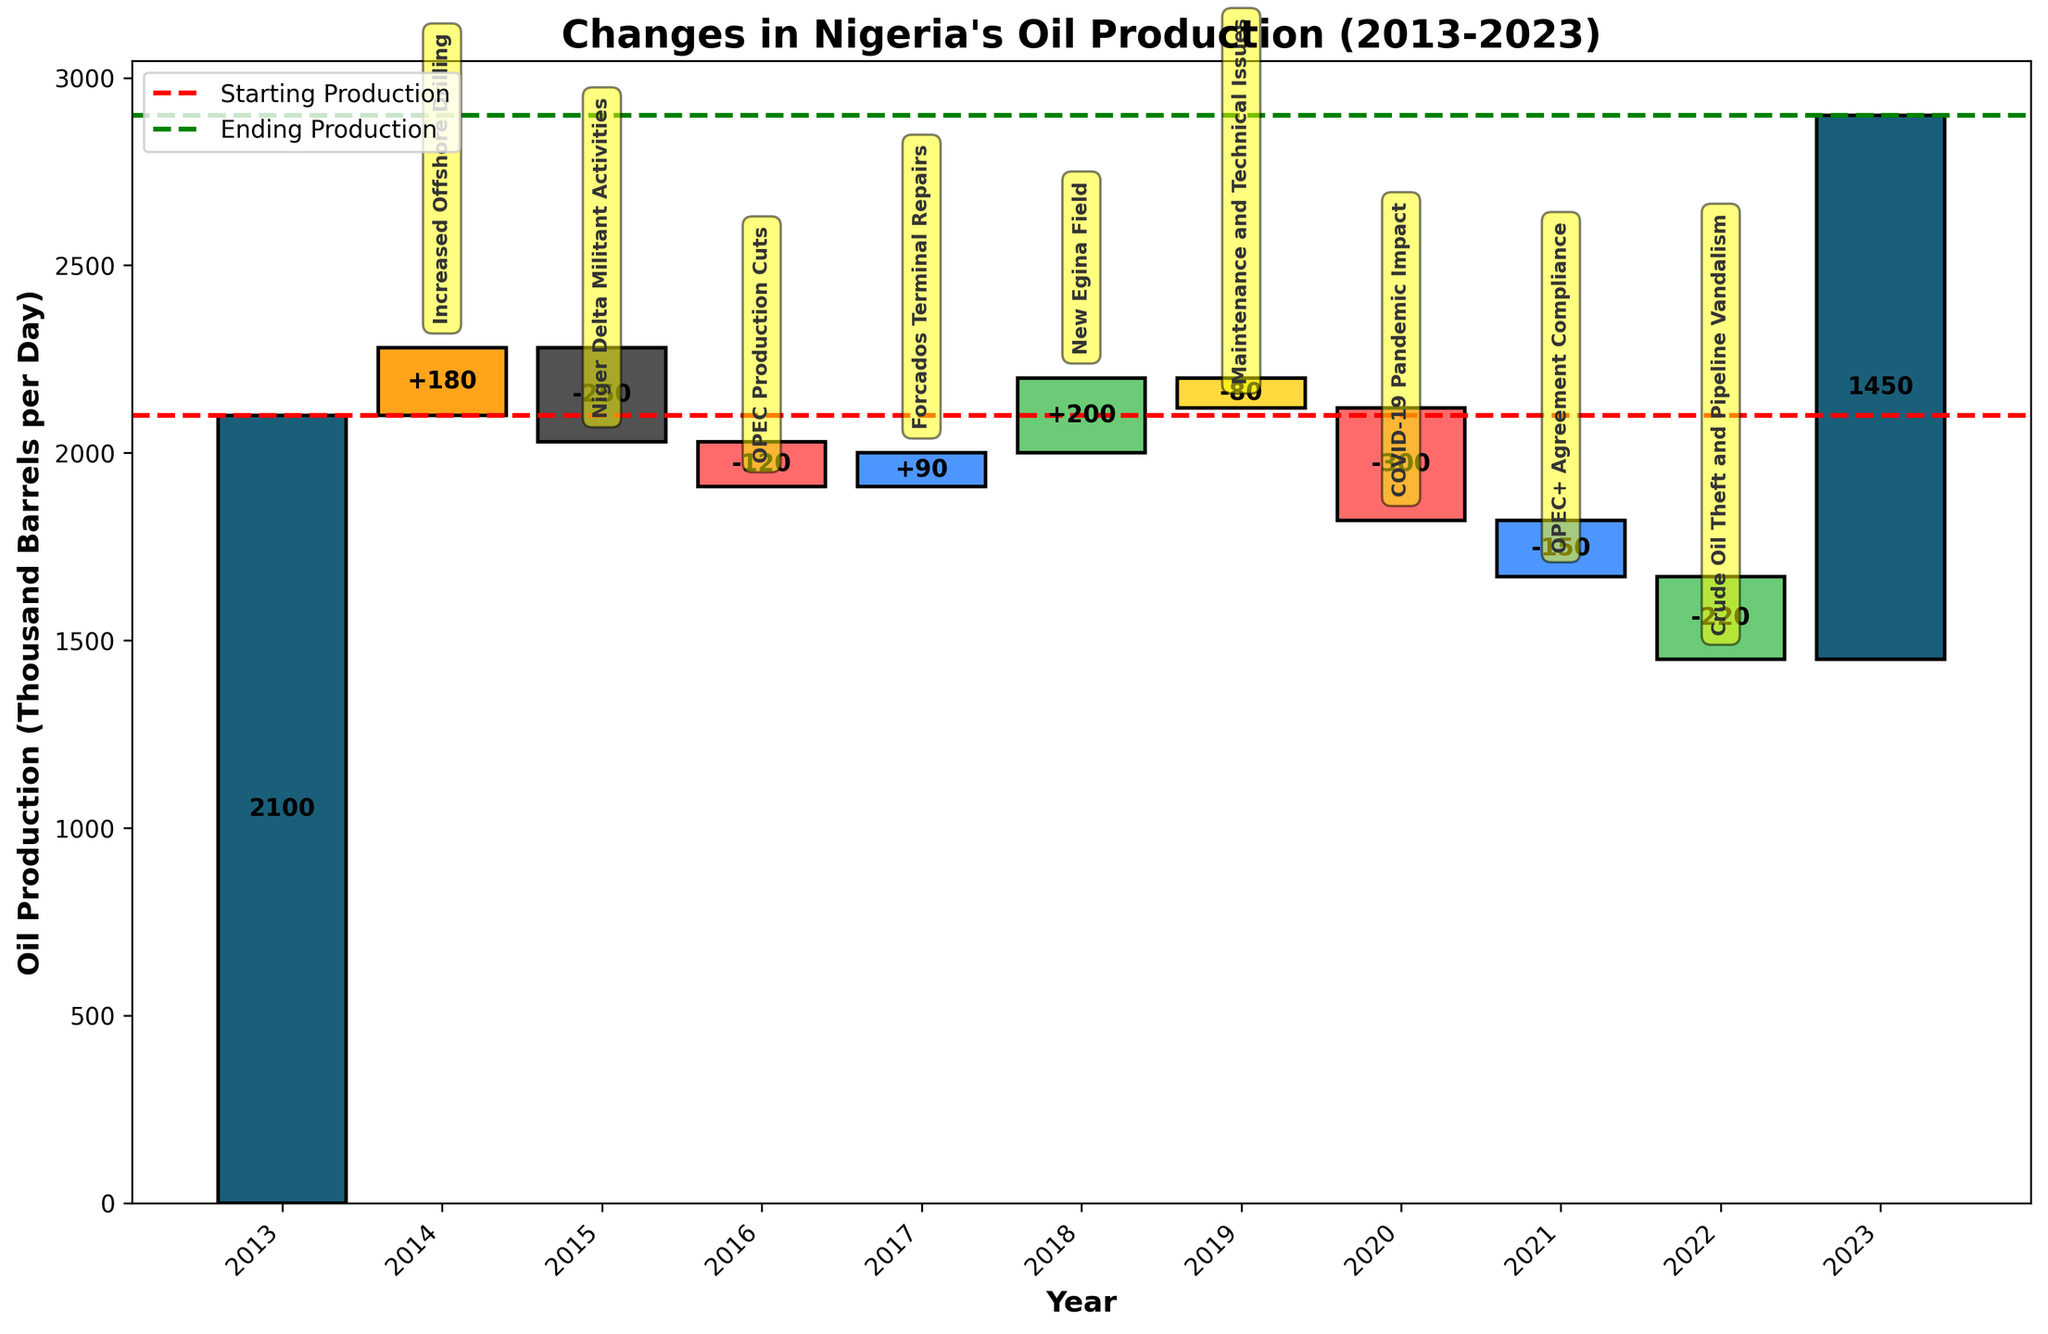How did the oil production value change from the starting to the ending production in the time period? The starting production value was 2100 thousand barrels per day, and the ending production value was 1450 thousand barrels per day. The change is calculated by subtracting the ending value from the starting value: 2100 - 1450 = 650.
Answer: 650 decrease Which year had the highest increase in oil production? We identify the years with positive changes and find the highest value among them. 2014 had an increase of +180, 2017 had +90, and 2018 had +200. The highest increase is in 2018.
Answer: 2018 What was the biggest factor leading to a decrease in oil production? We search for the largest negative change in oil production. The values for decreases are -250 in 2015, -120 in 2016, -80 in 2019, -300 in 2020, -150 in 2021, and -220 in 2022. The largest decrease is -300 in 2020 due to COVID-19 Pandemic Impact.
Answer: COVID-19 Pandemic Impact What was Nigeria's oil production value after the OPEC production cuts in 2016? The oil production value in 2016 was 2100 (starting value) + 180 (2014 increase) - 250 (2015 decrease) - 120 (2016 decrease), which cumulative lead to 1910 thousand barrels per day.
Answer: 1910 Between which two years did Nigeria experience the most significant drop in oil production? We identify the years with drops and calculate the changes: 2015 had -250, 2016 had -120, 2019 had -80, 2020 had -300, 2021 had -150, and 2022 had -220. The most significant drop was from 2019 to 2020, with a change of -300.
Answer: 2019 to 2020 What trends can be observed in Nigeria's oil production over the past decade? The trend can be observed by looking at the overall direction of changes. The starting value was 2100, with notable increases and decreases through the years, resulting in an ending value of 1450. A consistent downward trend is evident.
Answer: Downward What impact did Crude Oil Theft and Pipeline Vandalism have on oil production in 2022? In 2022, the oil production decreased by 220 thousand barrels per day due to Crude Oil Theft and Pipeline Vandalism.
Answer: 220 decrease How much did the repairs at the Forcados Terminal increase oil production? The repairs at the Forcados Terminal in 2017 increased oil production by 90 thousand barrels per day.
Answer: 90 What was the cumulative effect of OPEC-related agreements on Nigeria's oil production from 2016 to 2021? Add the changes attributed to OPEC-related agreements: -120 (2016) + (-150) (2021) = -270 thousand barrels per day.
Answer: -270 